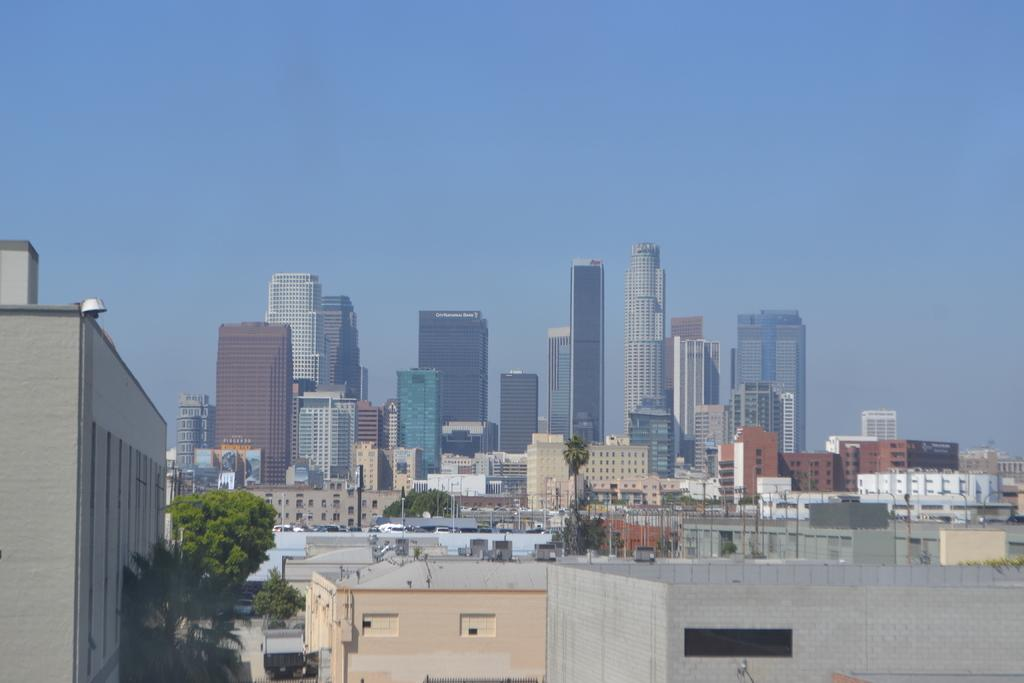What type of structures can be seen in the image? There are many buildings in the image. What other elements are present in the image besides buildings? There are trees, vehicles, and poles in the image. What can be seen in the sky in the image? The sky is visible in the image. Can you tell me how many goldfish are swimming in the sky in the image? There are no goldfish present in the image; the sky is visible but does not contain any fish. 